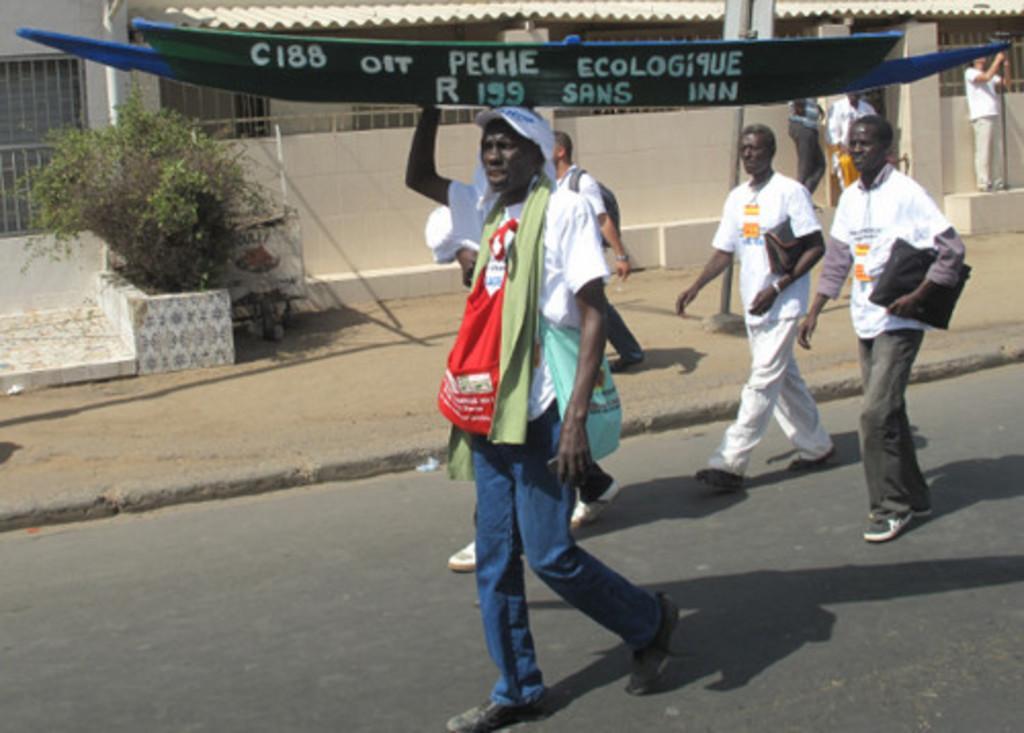In one or two sentences, can you explain what this image depicts? In the center of the image there is a person walking holding a boat on his head. In the background of the image there is a house. There is a plant. There are other people walking on the road. 